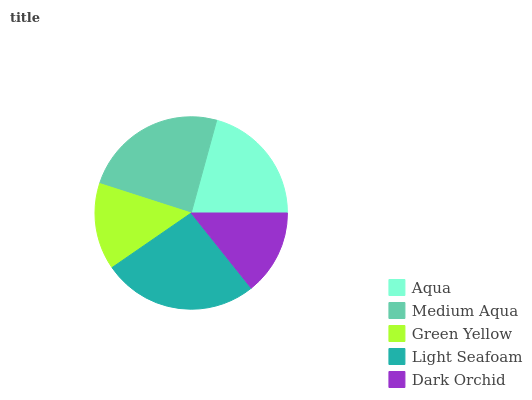Is Dark Orchid the minimum?
Answer yes or no. Yes. Is Light Seafoam the maximum?
Answer yes or no. Yes. Is Medium Aqua the minimum?
Answer yes or no. No. Is Medium Aqua the maximum?
Answer yes or no. No. Is Medium Aqua greater than Aqua?
Answer yes or no. Yes. Is Aqua less than Medium Aqua?
Answer yes or no. Yes. Is Aqua greater than Medium Aqua?
Answer yes or no. No. Is Medium Aqua less than Aqua?
Answer yes or no. No. Is Aqua the high median?
Answer yes or no. Yes. Is Aqua the low median?
Answer yes or no. Yes. Is Dark Orchid the high median?
Answer yes or no. No. Is Medium Aqua the low median?
Answer yes or no. No. 